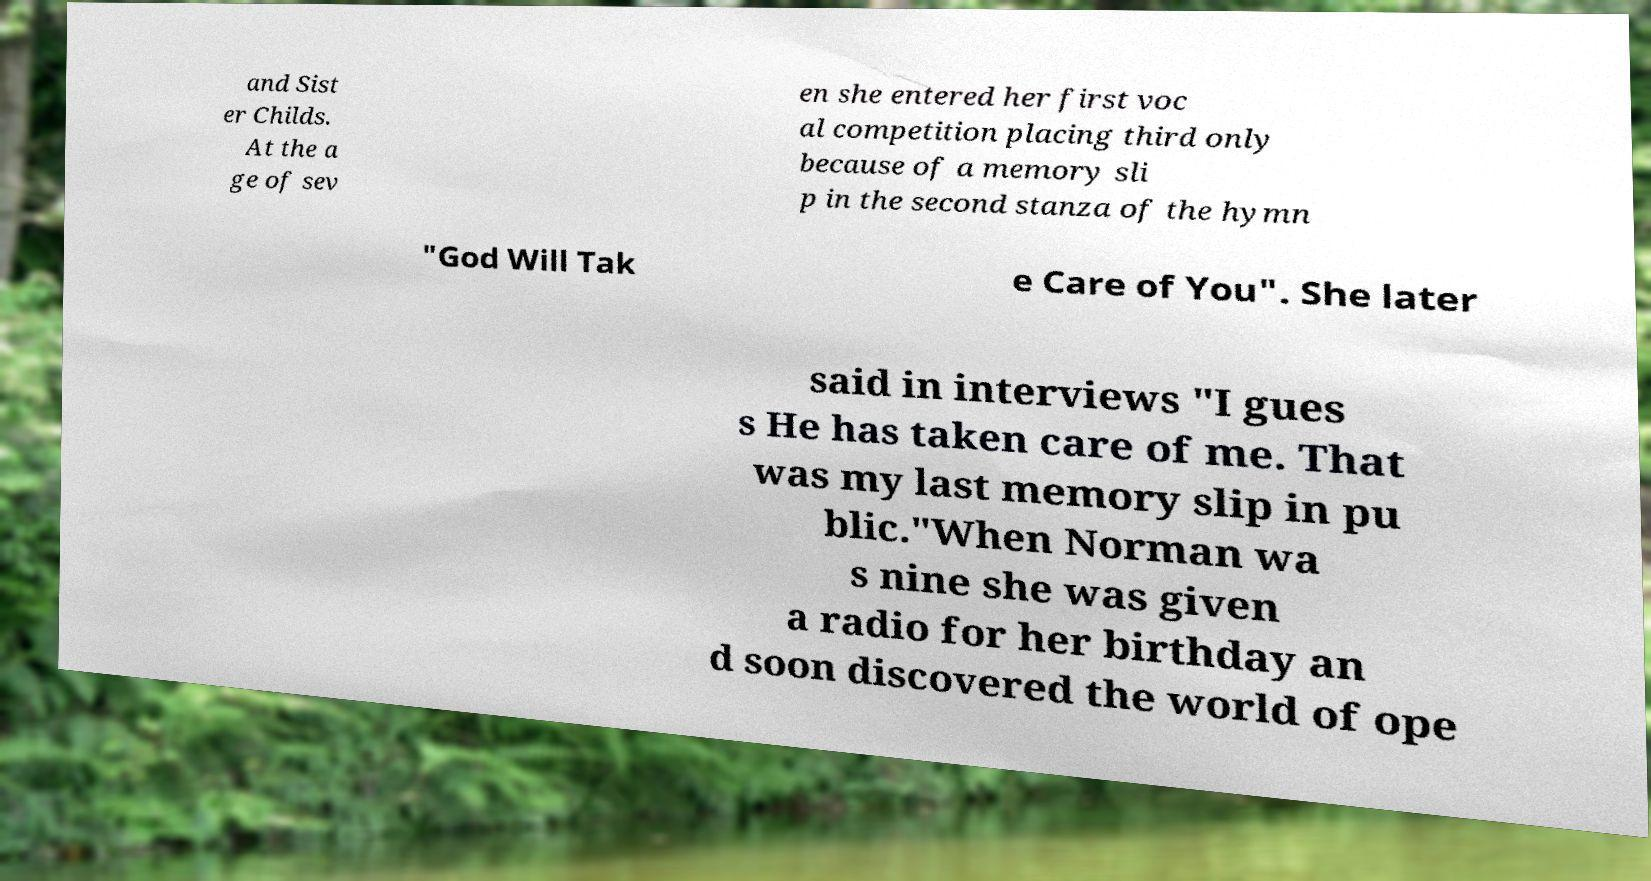Can you accurately transcribe the text from the provided image for me? and Sist er Childs. At the a ge of sev en she entered her first voc al competition placing third only because of a memory sli p in the second stanza of the hymn "God Will Tak e Care of You". She later said in interviews "I gues s He has taken care of me. That was my last memory slip in pu blic."When Norman wa s nine she was given a radio for her birthday an d soon discovered the world of ope 